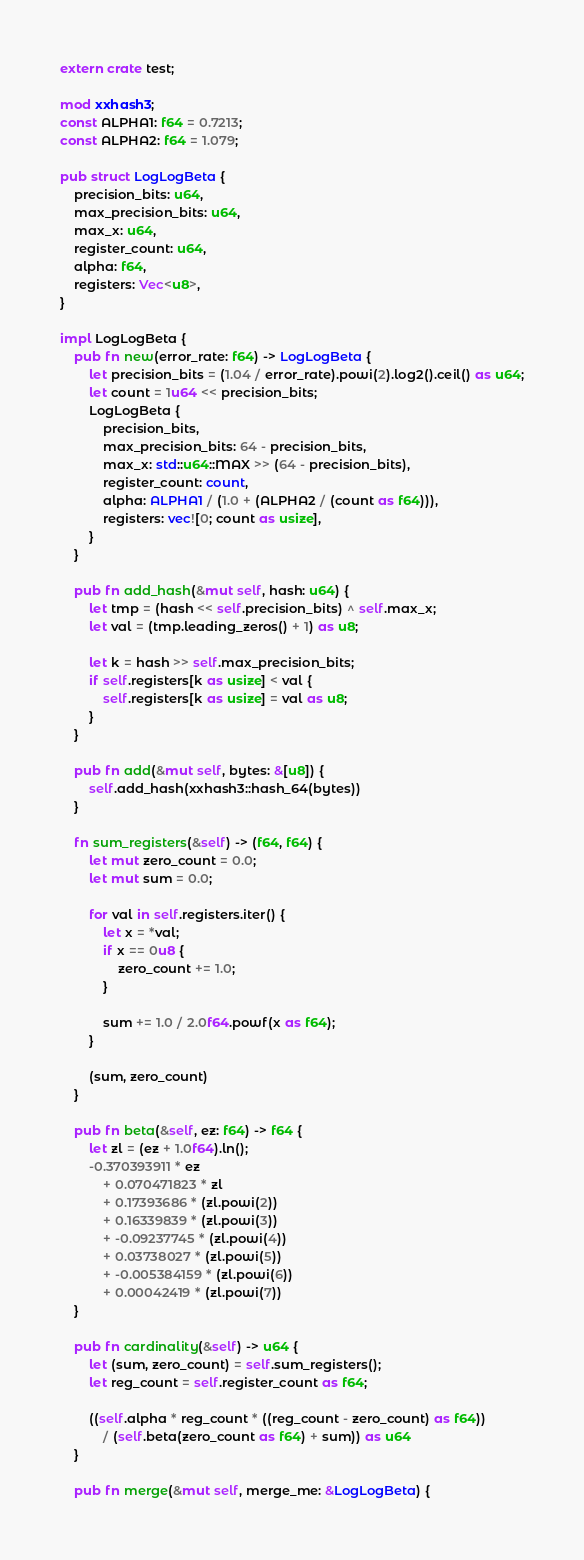Convert code to text. <code><loc_0><loc_0><loc_500><loc_500><_Rust_>extern crate test;

mod xxhash3;
const ALPHA1: f64 = 0.7213;
const ALPHA2: f64 = 1.079;

pub struct LogLogBeta {
    precision_bits: u64,
    max_precision_bits: u64,
    max_x: u64,
    register_count: u64,
    alpha: f64,
    registers: Vec<u8>,
}

impl LogLogBeta {
    pub fn new(error_rate: f64) -> LogLogBeta {
        let precision_bits = (1.04 / error_rate).powi(2).log2().ceil() as u64;
        let count = 1u64 << precision_bits;
        LogLogBeta {
            precision_bits,
            max_precision_bits: 64 - precision_bits,
            max_x: std::u64::MAX >> (64 - precision_bits),
            register_count: count,
            alpha: ALPHA1 / (1.0 + (ALPHA2 / (count as f64))),
            registers: vec![0; count as usize],
        }
    }

    pub fn add_hash(&mut self, hash: u64) {
        let tmp = (hash << self.precision_bits) ^ self.max_x;
        let val = (tmp.leading_zeros() + 1) as u8;

        let k = hash >> self.max_precision_bits;
        if self.registers[k as usize] < val {
            self.registers[k as usize] = val as u8;
        }
    }

    pub fn add(&mut self, bytes: &[u8]) {
        self.add_hash(xxhash3::hash_64(bytes))
    }

    fn sum_registers(&self) -> (f64, f64) {
        let mut zero_count = 0.0;
        let mut sum = 0.0;

        for val in self.registers.iter() {
            let x = *val;
            if x == 0u8 {
                zero_count += 1.0;
            }

            sum += 1.0 / 2.0f64.powf(x as f64);
        }

        (sum, zero_count)
    }

    pub fn beta(&self, ez: f64) -> f64 {
        let zl = (ez + 1.0f64).ln();
        -0.370393911 * ez
            + 0.070471823 * zl
            + 0.17393686 * (zl.powi(2))
            + 0.16339839 * (zl.powi(3))
            + -0.09237745 * (zl.powi(4))
            + 0.03738027 * (zl.powi(5))
            + -0.005384159 * (zl.powi(6))
            + 0.00042419 * (zl.powi(7))
    }

    pub fn cardinality(&self) -> u64 {
        let (sum, zero_count) = self.sum_registers();
        let reg_count = self.register_count as f64;

        ((self.alpha * reg_count * ((reg_count - zero_count) as f64))
            / (self.beta(zero_count as f64) + sum)) as u64
    }

    pub fn merge(&mut self, merge_me: &LogLogBeta) {</code> 